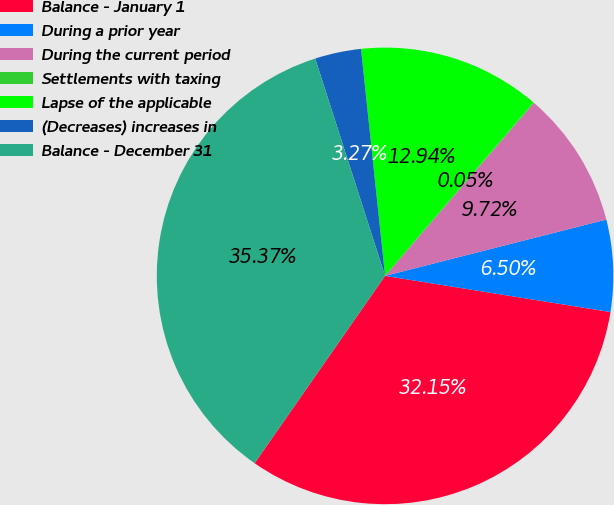Convert chart to OTSL. <chart><loc_0><loc_0><loc_500><loc_500><pie_chart><fcel>Balance - January 1<fcel>During a prior year<fcel>During the current period<fcel>Settlements with taxing<fcel>Lapse of the applicable<fcel>(Decreases) increases in<fcel>Balance - December 31<nl><fcel>32.15%<fcel>6.5%<fcel>9.72%<fcel>0.05%<fcel>12.94%<fcel>3.27%<fcel>35.37%<nl></chart> 